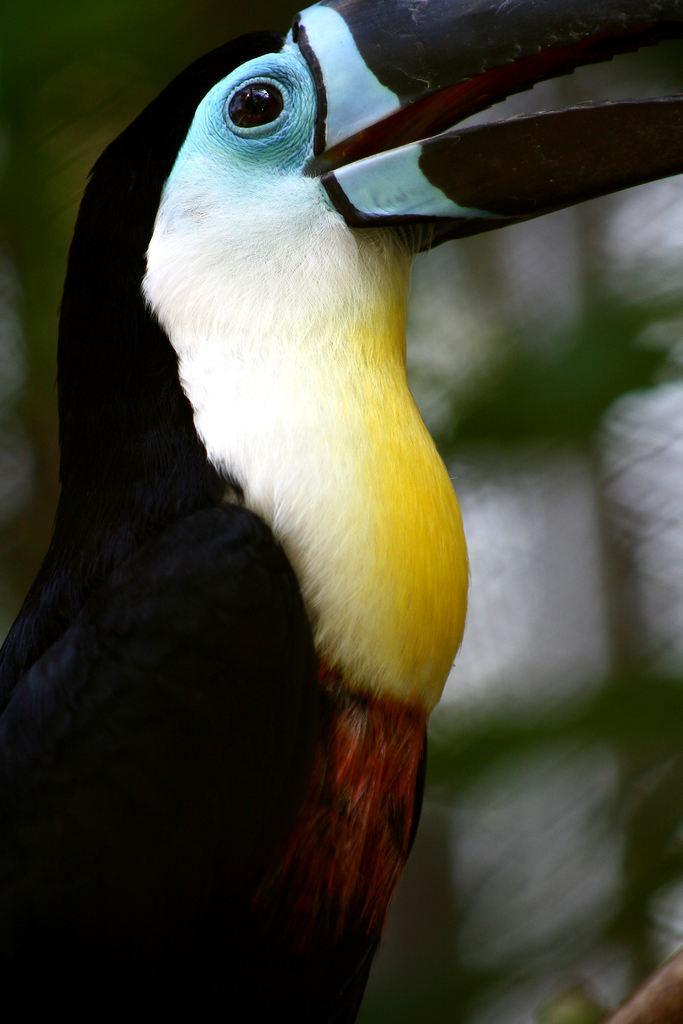What type of animal is in the picture? There is a bird in the picture. Can you describe the bird's coloring? The bird has black, white, and yellow coloring. What color is the bird's beak? The bird's beak is black in color. How would you describe the size of the bird's beak? The bird's beak is described as huge. What type of agreement did the bird make at the market in the image? There is no market or agreement present in the image; it features a bird with specific coloring and a huge beak. 